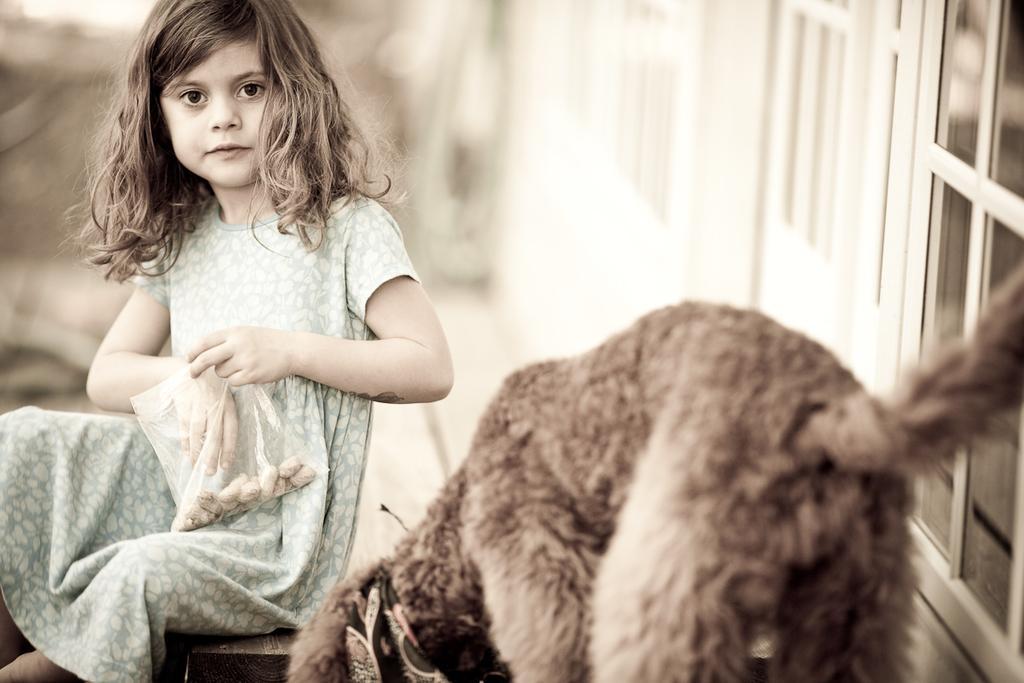Describe this image in one or two sentences. In this image there is a girl sitting on the floor by holding the packet. In front of her there is a dog. At the background there is a building. 